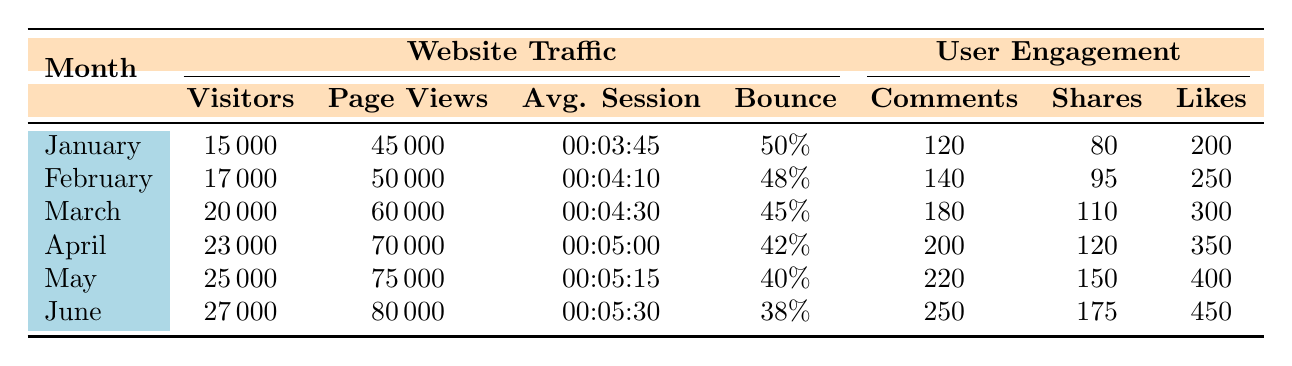What was the number of Visitors in June? According to the table, the data shows that the number of Visitors in June is 27000.
Answer: 27000 Which month had the highest Average Session Duration? The table indicates that the Average Session Duration increased over the months, with June having the highest value of 00:05:30.
Answer: June What is the total number of Shares from January to June? To find the total number of Shares, we add the Shares for each month: 80 (January) + 95 (February) + 110 (March) + 120 (April) + 150 (May) + 175 (June) = 830.
Answer: 830 Did the Bounce Rate decrease every month? Analyzing the table values, it shows the Bounce Rates in January (50%), February (48%), March (45%), April (42%), May (40%), and June (38%) are all decreasing. Therefore, the statement is true.
Answer: Yes What was the increase in Page Views from January to June? To calculate the increase in Page Views, subtract January's Page Views (45000) from June's (80000): 80000 - 45000 = 35000.
Answer: 35000 Which month had the lowest Bounce Rate and what was it? By examining the table, the month with the lowest Bounce Rate is June, which is reported at 38%.
Answer: 38% How many total Likes were recorded in April and May combined? The Likes for April is 350 and for May is 400. Adding these together gives 350 + 400 = 750.
Answer: 750 Was there more than 200 Comments in May? The table shows that May recorded 220 Comments, which is indeed more than 200. Therefore, the answer is yes.
Answer: Yes 